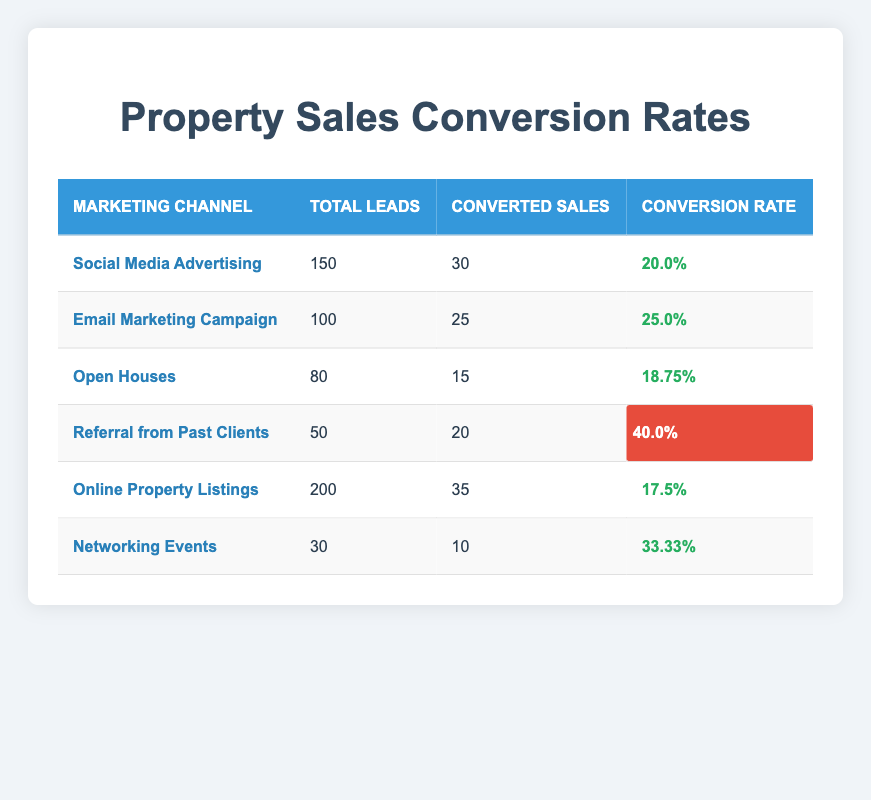What is the conversion rate for Social Media Advertising? Referring to the table, the conversion rate for Social Media Advertising is listed as 20.0%.
Answer: 20.0% How many leads were converted from the Email Marketing Campaign? According to the table, the Email Marketing Campaign converted 25 leads.
Answer: 25 Which marketing channel had the highest total number of leads? By examining the total leads for each marketing channel, Online Property Listings has the highest with 200 leads.
Answer: 200 What is the average conversion rate of Networking Events and Open Houses? The conversion rate for Networking Events is 33.33% and for Open Houses, it is 18.75%. First, we sum these rates: 33.33 + 18.75 = 52.08, then divide by 2 to get the average: 52.08 / 2 = 26.04%.
Answer: 26.04% Is the conversion rate for Referral from Past Clients higher than that of Online Property Listings? The Referral from Past Clients has a conversion rate of 40.0%, which is indeed higher than Online Property Listings at 17.5%. Thus, the statement is true.
Answer: Yes What is the total number of converted sales from all marketing channels combined? We sum the converted sales from each channel: 30 + 25 + 15 + 20 + 35 + 10 = 135.
Answer: 135 Which marketing channel has the lowest conversion rate? By reviewing the conversion rates, Online Property Listings has the lowest at 17.5%.
Answer: 17.5% What is the difference in conversion rates between Referral from Past Clients and Social Media Advertising? Referral from Past Clients has a conversion rate of 40.0% and Social Media Advertising has 20.0%. The difference is 40.0 - 20.0 = 20.0%.
Answer: 20.0% 